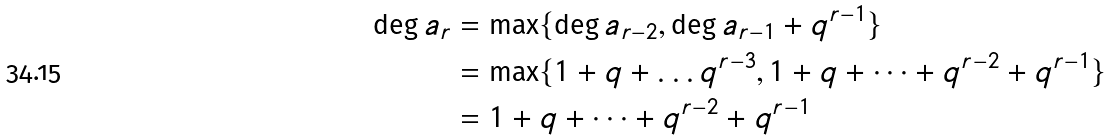Convert formula to latex. <formula><loc_0><loc_0><loc_500><loc_500>\deg a _ { r } & = \max \{ \deg a _ { r - 2 } , \deg a _ { r - 1 } + q ^ { r - 1 } \} \\ & = \max \{ 1 + q + \dots q ^ { r - 3 } , 1 + q + \dots + q ^ { r - 2 } + q ^ { r - 1 } \} \\ & = 1 + q + \dots + q ^ { r - 2 } + q ^ { r - 1 }</formula> 